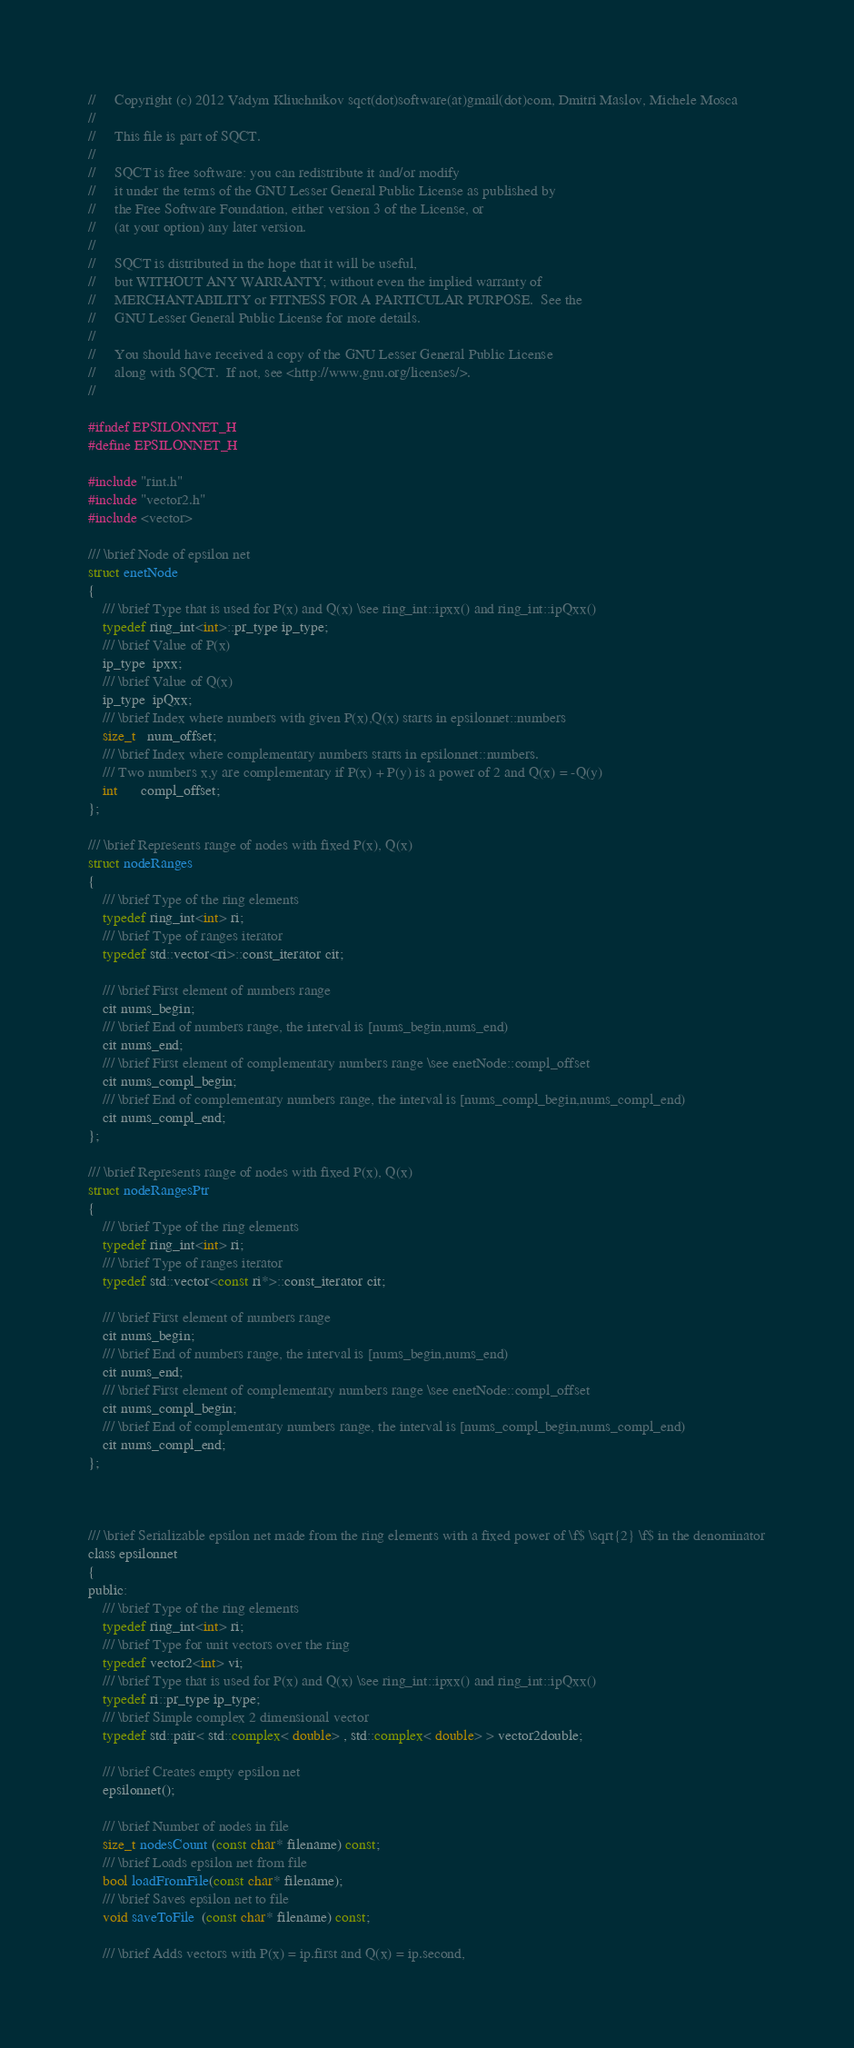<code> <loc_0><loc_0><loc_500><loc_500><_C_>//     Copyright (c) 2012 Vadym Kliuchnikov sqct(dot)software(at)gmail(dot)com, Dmitri Maslov, Michele Mosca
//
//     This file is part of SQCT.
// 
//     SQCT is free software: you can redistribute it and/or modify
//     it under the terms of the GNU Lesser General Public License as published by
//     the Free Software Foundation, either version 3 of the License, or
//     (at your option) any later version.
// 
//     SQCT is distributed in the hope that it will be useful,
//     but WITHOUT ANY WARRANTY; without even the implied warranty of
//     MERCHANTABILITY or FITNESS FOR A PARTICULAR PURPOSE.  See the
//     GNU Lesser General Public License for more details.
// 
//     You should have received a copy of the GNU Lesser General Public License
//     along with SQCT.  If not, see <http://www.gnu.org/licenses/>.
// 

#ifndef EPSILONNET_H
#define EPSILONNET_H

#include "rint.h"
#include "vector2.h"
#include <vector>

/// \brief Node of epsilon net
struct enetNode
{
    /// \brief Type that is used for P(x) and Q(x) \see ring_int::ipxx() and ring_int::ipQxx()
    typedef ring_int<int>::pr_type ip_type;
    /// \brief Value of P(x)
    ip_type  ipxx;
    /// \brief Value of Q(x)
    ip_type  ipQxx;
    /// \brief Index where numbers with given P(x),Q(x) starts in epsilonnet::numbers
    size_t   num_offset;
    /// \brief Index where complementary numbers starts in epsilonnet::numbers.
    /// Two numbers x,y are complementary if P(x) + P(y) is a power of 2 and Q(x) = -Q(y)
    int      compl_offset;
};

/// \brief Represents range of nodes with fixed P(x), Q(x)
struct nodeRanges
{
    /// \brief Type of the ring elements
    typedef ring_int<int> ri;
    /// \brief Type of ranges iterator
    typedef std::vector<ri>::const_iterator cit;

    /// \brief First element of numbers range
    cit nums_begin;
    /// \brief End of numbers range, the interval is [nums_begin,nums_end)
    cit nums_end;
    /// \brief First element of complementary numbers range \see enetNode::compl_offset
    cit nums_compl_begin;
    /// \brief End of complementary numbers range, the interval is [nums_compl_begin,nums_compl_end)
    cit nums_compl_end;
};

/// \brief Represents range of nodes with fixed P(x), Q(x)
struct nodeRangesPtr
{
    /// \brief Type of the ring elements
    typedef ring_int<int> ri;
    /// \brief Type of ranges iterator
    typedef std::vector<const ri*>::const_iterator cit;

    /// \brief First element of numbers range
    cit nums_begin;
    /// \brief End of numbers range, the interval is [nums_begin,nums_end)
    cit nums_end;
    /// \brief First element of complementary numbers range \see enetNode::compl_offset
    cit nums_compl_begin;
    /// \brief End of complementary numbers range, the interval is [nums_compl_begin,nums_compl_end)
    cit nums_compl_end;
};



/// \brief Serializable epsilon net made from the ring elements with a fixed power of \f$ \sqrt{2} \f$ in the denominator
class epsilonnet
{
public:
    /// \brief Type of the ring elements
    typedef ring_int<int> ri;
    /// \brief Type for unit vectors over the ring
    typedef vector2<int> vi;
    /// \brief Type that is used for P(x) and Q(x) \see ring_int::ipxx() and ring_int::ipQxx()
    typedef ri::pr_type ip_type;
    /// \brief Simple complex 2 dimensional vector
    typedef std::pair< std::complex< double> , std::complex< double> > vector2double;

    /// \brief Creates empty epsilon net
    epsilonnet();

    /// \brief Number of nodes in file
    size_t nodesCount (const char* filename) const;
    /// \brief Loads epsilon net from file
    bool loadFromFile(const char* filename);
    /// \brief Saves epsilon net to file
    void saveToFile  (const char* filename) const;

    /// \brief Adds vectors with P(x) = ip.first and Q(x) = ip.second,</code> 